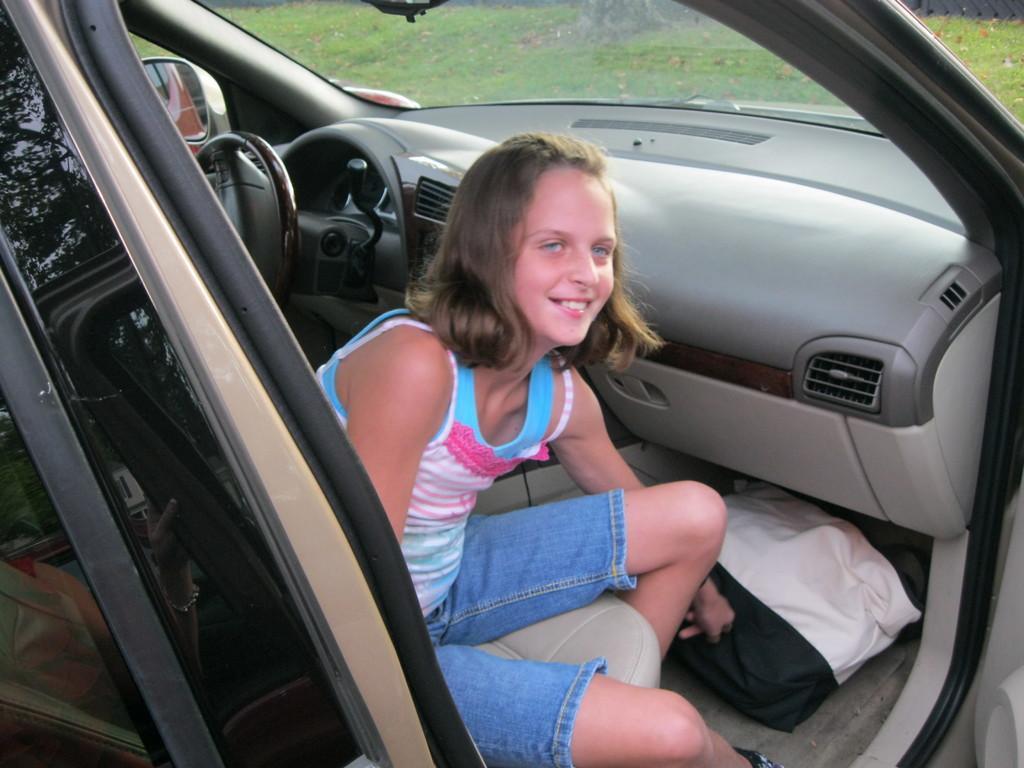How would you summarize this image in a sentence or two? In this picture we can see girl smiling sitting inside car and beside to her we can see a bag and at back of her we can see steering, mirror and from glass we can see grass. 